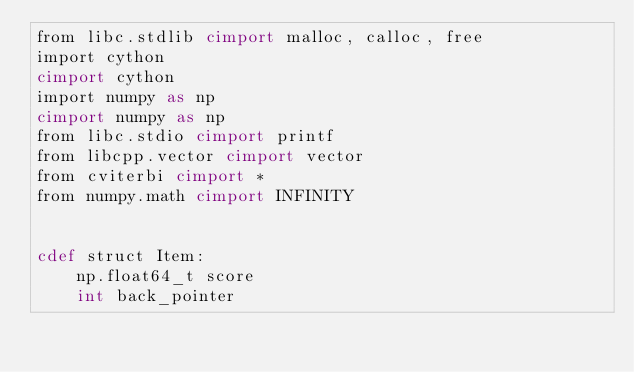Convert code to text. <code><loc_0><loc_0><loc_500><loc_500><_Cython_>from libc.stdlib cimport malloc, calloc, free
import cython
cimport cython
import numpy as np
cimport numpy as np
from libc.stdio cimport printf
from libcpp.vector cimport vector
from cviterbi cimport *
from numpy.math cimport INFINITY


cdef struct Item:
    np.float64_t score
    int back_pointer

</code> 